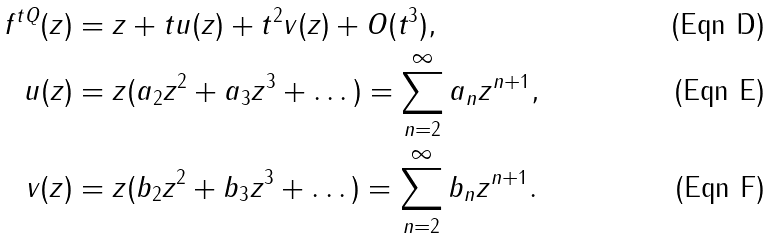Convert formula to latex. <formula><loc_0><loc_0><loc_500><loc_500>f ^ { t Q } ( z ) & = z + t u ( z ) + t ^ { 2 } v ( z ) + O ( t ^ { 3 } ) , \\ u ( z ) & = z ( a _ { 2 } z ^ { 2 } + a _ { 3 } z ^ { 3 } + \dots ) = \sum _ { n = 2 } ^ { \infty } a _ { n } z ^ { n + 1 } , \\ v ( z ) & = z ( b _ { 2 } z ^ { 2 } + b _ { 3 } z ^ { 3 } + \dots ) = \sum _ { n = 2 } ^ { \infty } b _ { n } z ^ { n + 1 } .</formula> 